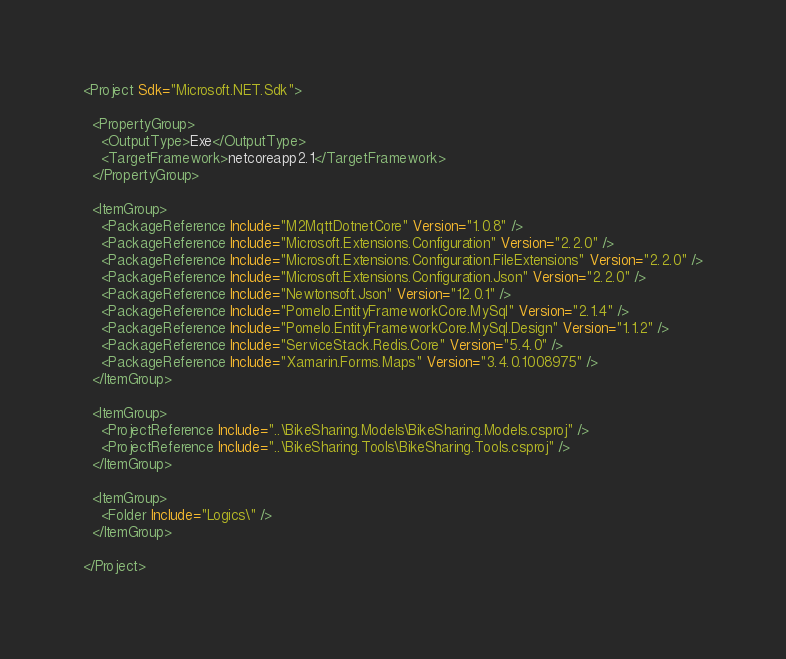Convert code to text. <code><loc_0><loc_0><loc_500><loc_500><_XML_><Project Sdk="Microsoft.NET.Sdk">

  <PropertyGroup>
    <OutputType>Exe</OutputType>
    <TargetFramework>netcoreapp2.1</TargetFramework>
  </PropertyGroup>

  <ItemGroup>
    <PackageReference Include="M2MqttDotnetCore" Version="1.0.8" />
    <PackageReference Include="Microsoft.Extensions.Configuration" Version="2.2.0" />
    <PackageReference Include="Microsoft.Extensions.Configuration.FileExtensions" Version="2.2.0" />
    <PackageReference Include="Microsoft.Extensions.Configuration.Json" Version="2.2.0" />
    <PackageReference Include="Newtonsoft.Json" Version="12.0.1" />
    <PackageReference Include="Pomelo.EntityFrameworkCore.MySql" Version="2.1.4" />
    <PackageReference Include="Pomelo.EntityFrameworkCore.MySql.Design" Version="1.1.2" />
    <PackageReference Include="ServiceStack.Redis.Core" Version="5.4.0" />
    <PackageReference Include="Xamarin.Forms.Maps" Version="3.4.0.1008975" />
  </ItemGroup>

  <ItemGroup>
    <ProjectReference Include="..\BikeSharing.Models\BikeSharing.Models.csproj" />
    <ProjectReference Include="..\BikeSharing.Tools\BikeSharing.Tools.csproj" />
  </ItemGroup>

  <ItemGroup>
    <Folder Include="Logics\" />
  </ItemGroup>

</Project>
</code> 